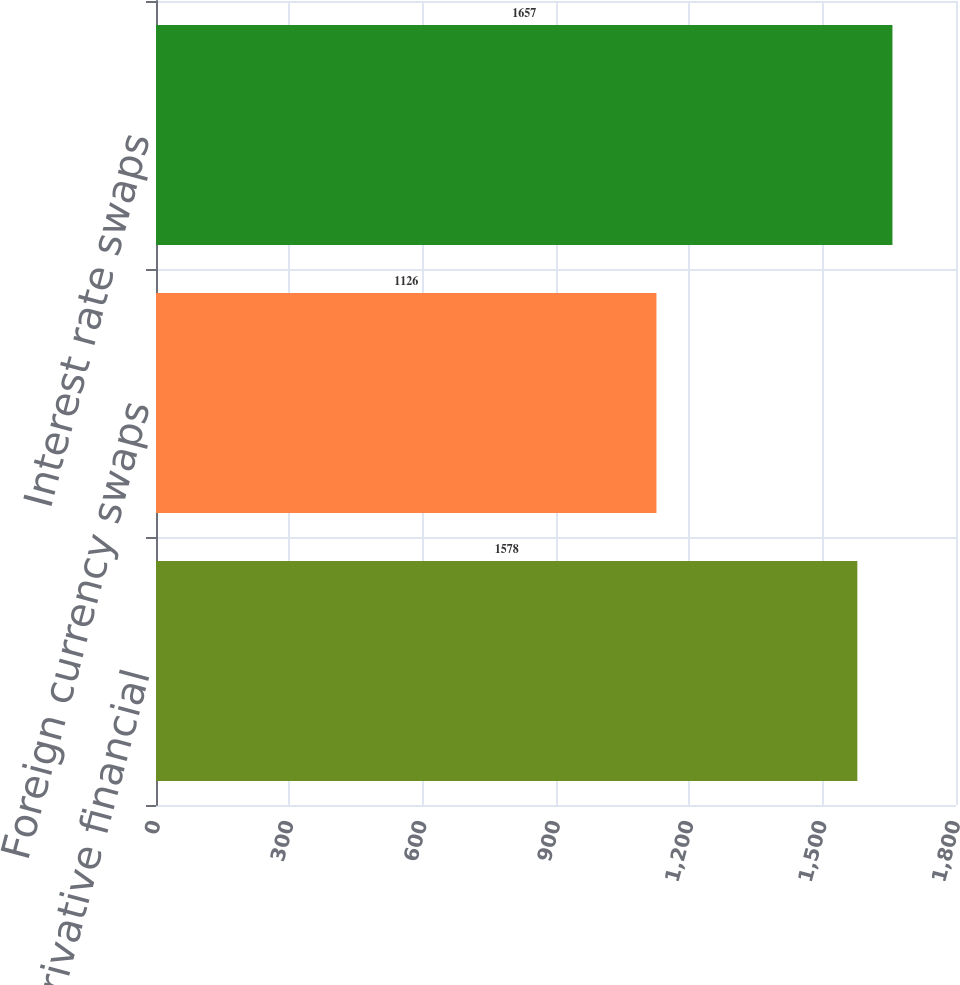Convert chart. <chart><loc_0><loc_0><loc_500><loc_500><bar_chart><fcel>Total derivative financial<fcel>Foreign currency swaps<fcel>Interest rate swaps<nl><fcel>1578<fcel>1126<fcel>1657<nl></chart> 